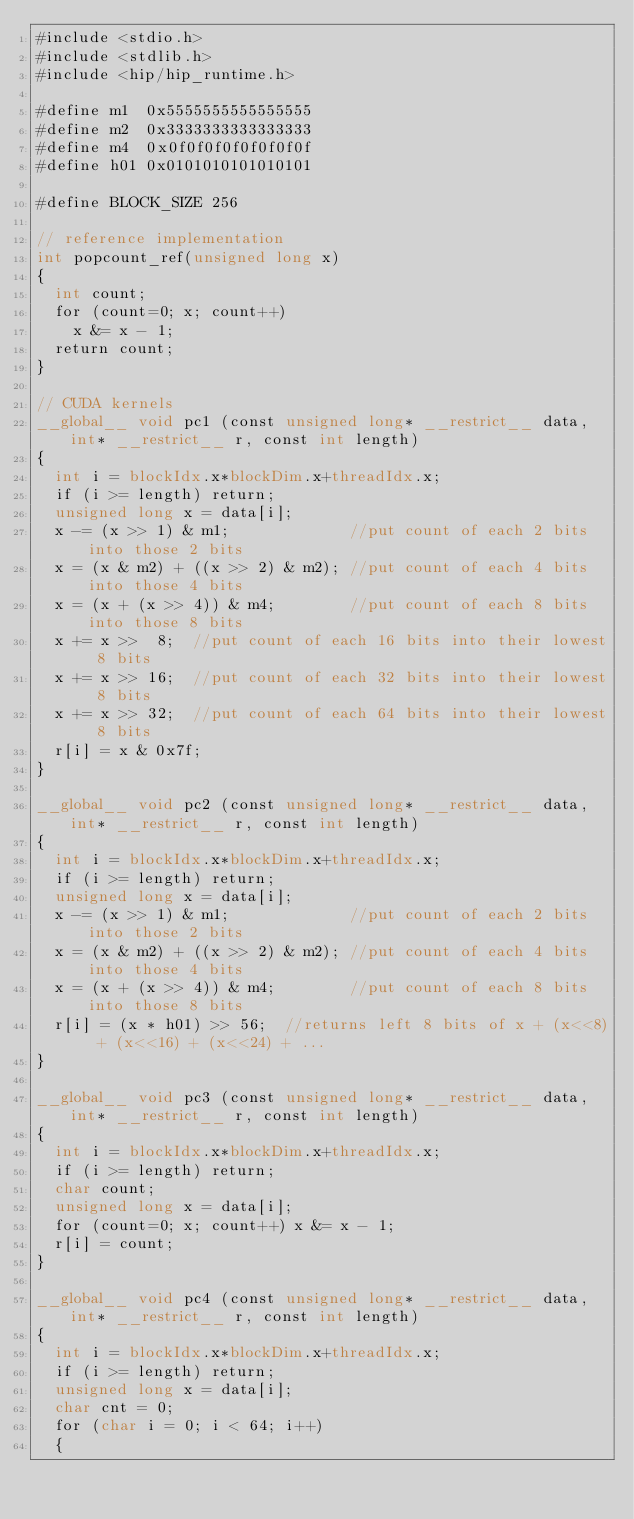<code> <loc_0><loc_0><loc_500><loc_500><_Cuda_>#include <stdio.h>
#include <stdlib.h>
#include <hip/hip_runtime.h>

#define m1  0x5555555555555555
#define m2  0x3333333333333333 
#define m4  0x0f0f0f0f0f0f0f0f 
#define h01 0x0101010101010101

#define BLOCK_SIZE 256

// reference implementation
int popcount_ref(unsigned long x)
{
  int count;
  for (count=0; x; count++)
    x &= x - 1;
  return count;
}

// CUDA kernels
__global__ void pc1 (const unsigned long* __restrict__ data,int* __restrict__ r, const int length)
{
  int i = blockIdx.x*blockDim.x+threadIdx.x;
  if (i >= length) return;
  unsigned long x = data[i];
  x -= (x >> 1) & m1;             //put count of each 2 bits into those 2 bits
  x = (x & m2) + ((x >> 2) & m2); //put count of each 4 bits into those 4 bits 
  x = (x + (x >> 4)) & m4;        //put count of each 8 bits into those 8 bits 
  x += x >>  8;  //put count of each 16 bits into their lowest 8 bits
  x += x >> 16;  //put count of each 32 bits into their lowest 8 bits
  x += x >> 32;  //put count of each 64 bits into their lowest 8 bits
  r[i] = x & 0x7f;
}

__global__ void pc2 (const unsigned long* __restrict__ data, int* __restrict__ r, const int length)
{
  int i = blockIdx.x*blockDim.x+threadIdx.x;
  if (i >= length) return;
  unsigned long x = data[i];
  x -= (x >> 1) & m1;             //put count of each 2 bits into those 2 bits
  x = (x & m2) + ((x >> 2) & m2); //put count of each 4 bits into those 4 bits 
  x = (x + (x >> 4)) & m4;        //put count of each 8 bits into those 8 bits 
  r[i] = (x * h01) >> 56;  //returns left 8 bits of x + (x<<8) + (x<<16) + (x<<24) + ... 
}

__global__ void pc3 (const unsigned long* __restrict__ data, int* __restrict__ r, const int length)
{
  int i = blockIdx.x*blockDim.x+threadIdx.x;
  if (i >= length) return;
  char count;
  unsigned long x = data[i];
  for (count=0; x; count++) x &= x - 1;
  r[i] = count;
}

__global__ void pc4 (const unsigned long* __restrict__ data, int* __restrict__ r, const int length)
{
  int i = blockIdx.x*blockDim.x+threadIdx.x;
  if (i >= length) return;
  unsigned long x = data[i];
  char cnt = 0;
  for (char i = 0; i < 64; i++)
  {</code> 